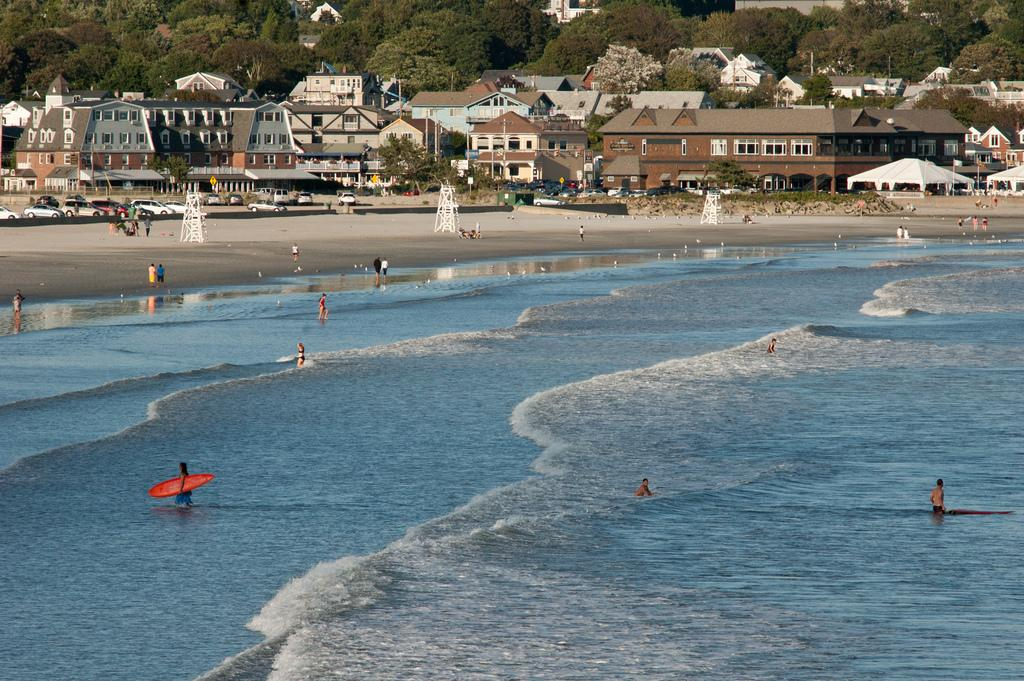What is the main setting of the image? The main setting of the image is a sea shore. What can be seen in the water in the image? There is no specific detail about the water in the image, but it is mentioned that there is water present. What type of structures are visible in the image? There are buildings in the image. What else is present on the sea shore in the image? There are white objects on the sea shore. How does the nose of the person in the image move while they are walking? There is no person walking in the image, and therefore no nose movement can be observed. 